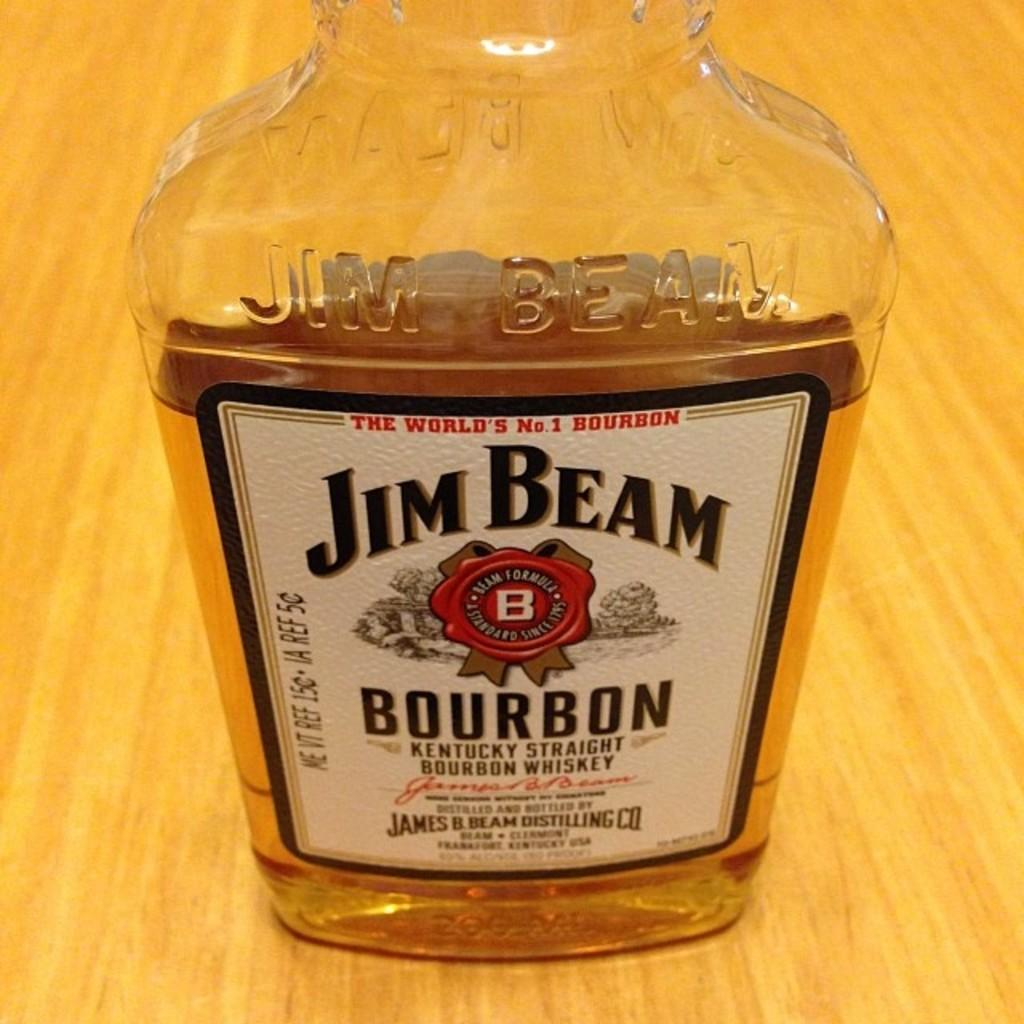<image>
Write a terse but informative summary of the picture. A close up of a half empty Jim Beam Burbon bottle. 